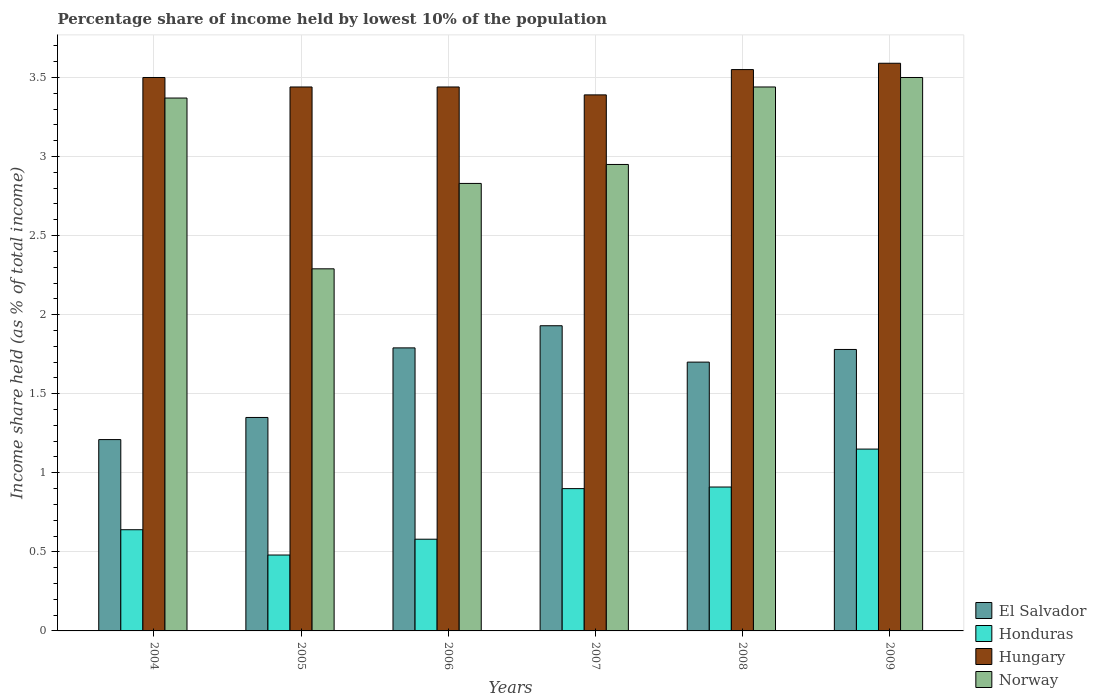Are the number of bars per tick equal to the number of legend labels?
Offer a terse response. Yes. Are the number of bars on each tick of the X-axis equal?
Your answer should be very brief. Yes. What is the label of the 6th group of bars from the left?
Your answer should be compact. 2009. What is the percentage share of income held by lowest 10% of the population in El Salvador in 2007?
Offer a terse response. 1.93. Across all years, what is the maximum percentage share of income held by lowest 10% of the population in Hungary?
Your response must be concise. 3.59. Across all years, what is the minimum percentage share of income held by lowest 10% of the population in Norway?
Provide a short and direct response. 2.29. In which year was the percentage share of income held by lowest 10% of the population in Honduras minimum?
Your answer should be compact. 2005. What is the total percentage share of income held by lowest 10% of the population in Hungary in the graph?
Give a very brief answer. 20.91. What is the difference between the percentage share of income held by lowest 10% of the population in El Salvador in 2007 and that in 2008?
Your answer should be compact. 0.23. What is the difference between the percentage share of income held by lowest 10% of the population in Norway in 2009 and the percentage share of income held by lowest 10% of the population in El Salvador in 2004?
Ensure brevity in your answer.  2.29. What is the average percentage share of income held by lowest 10% of the population in Hungary per year?
Make the answer very short. 3.48. In the year 2009, what is the difference between the percentage share of income held by lowest 10% of the population in El Salvador and percentage share of income held by lowest 10% of the population in Honduras?
Provide a succinct answer. 0.63. What is the ratio of the percentage share of income held by lowest 10% of the population in Norway in 2004 to that in 2006?
Provide a succinct answer. 1.19. Is the percentage share of income held by lowest 10% of the population in Honduras in 2006 less than that in 2009?
Offer a terse response. Yes. What is the difference between the highest and the second highest percentage share of income held by lowest 10% of the population in Hungary?
Your answer should be very brief. 0.04. What is the difference between the highest and the lowest percentage share of income held by lowest 10% of the population in Norway?
Provide a short and direct response. 1.21. In how many years, is the percentage share of income held by lowest 10% of the population in Hungary greater than the average percentage share of income held by lowest 10% of the population in Hungary taken over all years?
Ensure brevity in your answer.  3. Is it the case that in every year, the sum of the percentage share of income held by lowest 10% of the population in El Salvador and percentage share of income held by lowest 10% of the population in Norway is greater than the sum of percentage share of income held by lowest 10% of the population in Honduras and percentage share of income held by lowest 10% of the population in Hungary?
Your answer should be very brief. Yes. What does the 3rd bar from the right in 2008 represents?
Make the answer very short. Honduras. Is it the case that in every year, the sum of the percentage share of income held by lowest 10% of the population in Norway and percentage share of income held by lowest 10% of the population in Honduras is greater than the percentage share of income held by lowest 10% of the population in Hungary?
Your answer should be compact. No. Are all the bars in the graph horizontal?
Keep it short and to the point. No. Does the graph contain any zero values?
Your response must be concise. No. Does the graph contain grids?
Ensure brevity in your answer.  Yes. Where does the legend appear in the graph?
Offer a very short reply. Bottom right. How are the legend labels stacked?
Keep it short and to the point. Vertical. What is the title of the graph?
Provide a short and direct response. Percentage share of income held by lowest 10% of the population. Does "Zambia" appear as one of the legend labels in the graph?
Ensure brevity in your answer.  No. What is the label or title of the Y-axis?
Your answer should be very brief. Income share held (as % of total income). What is the Income share held (as % of total income) of El Salvador in 2004?
Keep it short and to the point. 1.21. What is the Income share held (as % of total income) in Honduras in 2004?
Ensure brevity in your answer.  0.64. What is the Income share held (as % of total income) in Norway in 2004?
Provide a succinct answer. 3.37. What is the Income share held (as % of total income) of El Salvador in 2005?
Offer a very short reply. 1.35. What is the Income share held (as % of total income) of Honduras in 2005?
Ensure brevity in your answer.  0.48. What is the Income share held (as % of total income) of Hungary in 2005?
Provide a short and direct response. 3.44. What is the Income share held (as % of total income) of Norway in 2005?
Keep it short and to the point. 2.29. What is the Income share held (as % of total income) of El Salvador in 2006?
Provide a succinct answer. 1.79. What is the Income share held (as % of total income) in Honduras in 2006?
Ensure brevity in your answer.  0.58. What is the Income share held (as % of total income) in Hungary in 2006?
Offer a terse response. 3.44. What is the Income share held (as % of total income) in Norway in 2006?
Give a very brief answer. 2.83. What is the Income share held (as % of total income) in El Salvador in 2007?
Ensure brevity in your answer.  1.93. What is the Income share held (as % of total income) in Honduras in 2007?
Offer a terse response. 0.9. What is the Income share held (as % of total income) of Hungary in 2007?
Provide a short and direct response. 3.39. What is the Income share held (as % of total income) in Norway in 2007?
Provide a succinct answer. 2.95. What is the Income share held (as % of total income) in Honduras in 2008?
Your response must be concise. 0.91. What is the Income share held (as % of total income) in Hungary in 2008?
Make the answer very short. 3.55. What is the Income share held (as % of total income) in Norway in 2008?
Offer a terse response. 3.44. What is the Income share held (as % of total income) of El Salvador in 2009?
Make the answer very short. 1.78. What is the Income share held (as % of total income) of Honduras in 2009?
Offer a very short reply. 1.15. What is the Income share held (as % of total income) of Hungary in 2009?
Provide a short and direct response. 3.59. Across all years, what is the maximum Income share held (as % of total income) in El Salvador?
Your response must be concise. 1.93. Across all years, what is the maximum Income share held (as % of total income) in Honduras?
Your response must be concise. 1.15. Across all years, what is the maximum Income share held (as % of total income) in Hungary?
Your answer should be compact. 3.59. Across all years, what is the maximum Income share held (as % of total income) in Norway?
Offer a very short reply. 3.5. Across all years, what is the minimum Income share held (as % of total income) of El Salvador?
Your answer should be very brief. 1.21. Across all years, what is the minimum Income share held (as % of total income) of Honduras?
Your response must be concise. 0.48. Across all years, what is the minimum Income share held (as % of total income) in Hungary?
Your answer should be very brief. 3.39. Across all years, what is the minimum Income share held (as % of total income) in Norway?
Provide a short and direct response. 2.29. What is the total Income share held (as % of total income) of El Salvador in the graph?
Offer a terse response. 9.76. What is the total Income share held (as % of total income) of Honduras in the graph?
Provide a succinct answer. 4.66. What is the total Income share held (as % of total income) in Hungary in the graph?
Your answer should be very brief. 20.91. What is the total Income share held (as % of total income) in Norway in the graph?
Ensure brevity in your answer.  18.38. What is the difference between the Income share held (as % of total income) in El Salvador in 2004 and that in 2005?
Make the answer very short. -0.14. What is the difference between the Income share held (as % of total income) in Honduras in 2004 and that in 2005?
Make the answer very short. 0.16. What is the difference between the Income share held (as % of total income) of El Salvador in 2004 and that in 2006?
Make the answer very short. -0.58. What is the difference between the Income share held (as % of total income) in Norway in 2004 and that in 2006?
Your response must be concise. 0.54. What is the difference between the Income share held (as % of total income) in El Salvador in 2004 and that in 2007?
Offer a very short reply. -0.72. What is the difference between the Income share held (as % of total income) in Honduras in 2004 and that in 2007?
Keep it short and to the point. -0.26. What is the difference between the Income share held (as % of total income) of Hungary in 2004 and that in 2007?
Make the answer very short. 0.11. What is the difference between the Income share held (as % of total income) of Norway in 2004 and that in 2007?
Provide a succinct answer. 0.42. What is the difference between the Income share held (as % of total income) in El Salvador in 2004 and that in 2008?
Offer a terse response. -0.49. What is the difference between the Income share held (as % of total income) in Honduras in 2004 and that in 2008?
Provide a succinct answer. -0.27. What is the difference between the Income share held (as % of total income) in Hungary in 2004 and that in 2008?
Provide a short and direct response. -0.05. What is the difference between the Income share held (as % of total income) in Norway in 2004 and that in 2008?
Your response must be concise. -0.07. What is the difference between the Income share held (as % of total income) of El Salvador in 2004 and that in 2009?
Offer a terse response. -0.57. What is the difference between the Income share held (as % of total income) in Honduras in 2004 and that in 2009?
Your answer should be compact. -0.51. What is the difference between the Income share held (as % of total income) of Hungary in 2004 and that in 2009?
Provide a short and direct response. -0.09. What is the difference between the Income share held (as % of total income) of Norway in 2004 and that in 2009?
Your answer should be compact. -0.13. What is the difference between the Income share held (as % of total income) of El Salvador in 2005 and that in 2006?
Give a very brief answer. -0.44. What is the difference between the Income share held (as % of total income) in Honduras in 2005 and that in 2006?
Your response must be concise. -0.1. What is the difference between the Income share held (as % of total income) of Norway in 2005 and that in 2006?
Make the answer very short. -0.54. What is the difference between the Income share held (as % of total income) in El Salvador in 2005 and that in 2007?
Your answer should be very brief. -0.58. What is the difference between the Income share held (as % of total income) in Honduras in 2005 and that in 2007?
Offer a terse response. -0.42. What is the difference between the Income share held (as % of total income) of Hungary in 2005 and that in 2007?
Your answer should be very brief. 0.05. What is the difference between the Income share held (as % of total income) in Norway in 2005 and that in 2007?
Offer a terse response. -0.66. What is the difference between the Income share held (as % of total income) of El Salvador in 2005 and that in 2008?
Offer a very short reply. -0.35. What is the difference between the Income share held (as % of total income) of Honduras in 2005 and that in 2008?
Your answer should be very brief. -0.43. What is the difference between the Income share held (as % of total income) in Hungary in 2005 and that in 2008?
Provide a short and direct response. -0.11. What is the difference between the Income share held (as % of total income) of Norway in 2005 and that in 2008?
Offer a terse response. -1.15. What is the difference between the Income share held (as % of total income) in El Salvador in 2005 and that in 2009?
Your answer should be very brief. -0.43. What is the difference between the Income share held (as % of total income) in Honduras in 2005 and that in 2009?
Your answer should be compact. -0.67. What is the difference between the Income share held (as % of total income) of Hungary in 2005 and that in 2009?
Provide a succinct answer. -0.15. What is the difference between the Income share held (as % of total income) in Norway in 2005 and that in 2009?
Your answer should be compact. -1.21. What is the difference between the Income share held (as % of total income) in El Salvador in 2006 and that in 2007?
Your response must be concise. -0.14. What is the difference between the Income share held (as % of total income) of Honduras in 2006 and that in 2007?
Your answer should be very brief. -0.32. What is the difference between the Income share held (as % of total income) in Norway in 2006 and that in 2007?
Give a very brief answer. -0.12. What is the difference between the Income share held (as % of total income) of El Salvador in 2006 and that in 2008?
Offer a very short reply. 0.09. What is the difference between the Income share held (as % of total income) of Honduras in 2006 and that in 2008?
Offer a terse response. -0.33. What is the difference between the Income share held (as % of total income) in Hungary in 2006 and that in 2008?
Provide a succinct answer. -0.11. What is the difference between the Income share held (as % of total income) in Norway in 2006 and that in 2008?
Keep it short and to the point. -0.61. What is the difference between the Income share held (as % of total income) in Honduras in 2006 and that in 2009?
Give a very brief answer. -0.57. What is the difference between the Income share held (as % of total income) of Norway in 2006 and that in 2009?
Make the answer very short. -0.67. What is the difference between the Income share held (as % of total income) in El Salvador in 2007 and that in 2008?
Your answer should be very brief. 0.23. What is the difference between the Income share held (as % of total income) in Honduras in 2007 and that in 2008?
Offer a very short reply. -0.01. What is the difference between the Income share held (as % of total income) of Hungary in 2007 and that in 2008?
Provide a succinct answer. -0.16. What is the difference between the Income share held (as % of total income) of Norway in 2007 and that in 2008?
Offer a very short reply. -0.49. What is the difference between the Income share held (as % of total income) of Hungary in 2007 and that in 2009?
Offer a terse response. -0.2. What is the difference between the Income share held (as % of total income) in Norway in 2007 and that in 2009?
Your answer should be compact. -0.55. What is the difference between the Income share held (as % of total income) of El Salvador in 2008 and that in 2009?
Your answer should be compact. -0.08. What is the difference between the Income share held (as % of total income) of Honduras in 2008 and that in 2009?
Provide a succinct answer. -0.24. What is the difference between the Income share held (as % of total income) of Hungary in 2008 and that in 2009?
Your answer should be very brief. -0.04. What is the difference between the Income share held (as % of total income) of Norway in 2008 and that in 2009?
Keep it short and to the point. -0.06. What is the difference between the Income share held (as % of total income) in El Salvador in 2004 and the Income share held (as % of total income) in Honduras in 2005?
Provide a short and direct response. 0.73. What is the difference between the Income share held (as % of total income) in El Salvador in 2004 and the Income share held (as % of total income) in Hungary in 2005?
Make the answer very short. -2.23. What is the difference between the Income share held (as % of total income) in El Salvador in 2004 and the Income share held (as % of total income) in Norway in 2005?
Give a very brief answer. -1.08. What is the difference between the Income share held (as % of total income) of Honduras in 2004 and the Income share held (as % of total income) of Hungary in 2005?
Provide a short and direct response. -2.8. What is the difference between the Income share held (as % of total income) in Honduras in 2004 and the Income share held (as % of total income) in Norway in 2005?
Your response must be concise. -1.65. What is the difference between the Income share held (as % of total income) of Hungary in 2004 and the Income share held (as % of total income) of Norway in 2005?
Give a very brief answer. 1.21. What is the difference between the Income share held (as % of total income) of El Salvador in 2004 and the Income share held (as % of total income) of Honduras in 2006?
Provide a succinct answer. 0.63. What is the difference between the Income share held (as % of total income) of El Salvador in 2004 and the Income share held (as % of total income) of Hungary in 2006?
Provide a short and direct response. -2.23. What is the difference between the Income share held (as % of total income) of El Salvador in 2004 and the Income share held (as % of total income) of Norway in 2006?
Offer a terse response. -1.62. What is the difference between the Income share held (as % of total income) in Honduras in 2004 and the Income share held (as % of total income) in Hungary in 2006?
Keep it short and to the point. -2.8. What is the difference between the Income share held (as % of total income) of Honduras in 2004 and the Income share held (as % of total income) of Norway in 2006?
Offer a terse response. -2.19. What is the difference between the Income share held (as % of total income) of Hungary in 2004 and the Income share held (as % of total income) of Norway in 2006?
Offer a terse response. 0.67. What is the difference between the Income share held (as % of total income) in El Salvador in 2004 and the Income share held (as % of total income) in Honduras in 2007?
Offer a very short reply. 0.31. What is the difference between the Income share held (as % of total income) of El Salvador in 2004 and the Income share held (as % of total income) of Hungary in 2007?
Your answer should be very brief. -2.18. What is the difference between the Income share held (as % of total income) of El Salvador in 2004 and the Income share held (as % of total income) of Norway in 2007?
Offer a terse response. -1.74. What is the difference between the Income share held (as % of total income) of Honduras in 2004 and the Income share held (as % of total income) of Hungary in 2007?
Offer a terse response. -2.75. What is the difference between the Income share held (as % of total income) of Honduras in 2004 and the Income share held (as % of total income) of Norway in 2007?
Offer a terse response. -2.31. What is the difference between the Income share held (as % of total income) of Hungary in 2004 and the Income share held (as % of total income) of Norway in 2007?
Provide a succinct answer. 0.55. What is the difference between the Income share held (as % of total income) of El Salvador in 2004 and the Income share held (as % of total income) of Honduras in 2008?
Your answer should be very brief. 0.3. What is the difference between the Income share held (as % of total income) of El Salvador in 2004 and the Income share held (as % of total income) of Hungary in 2008?
Give a very brief answer. -2.34. What is the difference between the Income share held (as % of total income) of El Salvador in 2004 and the Income share held (as % of total income) of Norway in 2008?
Make the answer very short. -2.23. What is the difference between the Income share held (as % of total income) of Honduras in 2004 and the Income share held (as % of total income) of Hungary in 2008?
Ensure brevity in your answer.  -2.91. What is the difference between the Income share held (as % of total income) of Honduras in 2004 and the Income share held (as % of total income) of Norway in 2008?
Make the answer very short. -2.8. What is the difference between the Income share held (as % of total income) in El Salvador in 2004 and the Income share held (as % of total income) in Hungary in 2009?
Your response must be concise. -2.38. What is the difference between the Income share held (as % of total income) in El Salvador in 2004 and the Income share held (as % of total income) in Norway in 2009?
Provide a short and direct response. -2.29. What is the difference between the Income share held (as % of total income) of Honduras in 2004 and the Income share held (as % of total income) of Hungary in 2009?
Your response must be concise. -2.95. What is the difference between the Income share held (as % of total income) of Honduras in 2004 and the Income share held (as % of total income) of Norway in 2009?
Your response must be concise. -2.86. What is the difference between the Income share held (as % of total income) of Hungary in 2004 and the Income share held (as % of total income) of Norway in 2009?
Ensure brevity in your answer.  0. What is the difference between the Income share held (as % of total income) of El Salvador in 2005 and the Income share held (as % of total income) of Honduras in 2006?
Offer a very short reply. 0.77. What is the difference between the Income share held (as % of total income) in El Salvador in 2005 and the Income share held (as % of total income) in Hungary in 2006?
Offer a terse response. -2.09. What is the difference between the Income share held (as % of total income) in El Salvador in 2005 and the Income share held (as % of total income) in Norway in 2006?
Ensure brevity in your answer.  -1.48. What is the difference between the Income share held (as % of total income) in Honduras in 2005 and the Income share held (as % of total income) in Hungary in 2006?
Offer a terse response. -2.96. What is the difference between the Income share held (as % of total income) of Honduras in 2005 and the Income share held (as % of total income) of Norway in 2006?
Your answer should be compact. -2.35. What is the difference between the Income share held (as % of total income) in Hungary in 2005 and the Income share held (as % of total income) in Norway in 2006?
Provide a succinct answer. 0.61. What is the difference between the Income share held (as % of total income) of El Salvador in 2005 and the Income share held (as % of total income) of Honduras in 2007?
Give a very brief answer. 0.45. What is the difference between the Income share held (as % of total income) in El Salvador in 2005 and the Income share held (as % of total income) in Hungary in 2007?
Offer a terse response. -2.04. What is the difference between the Income share held (as % of total income) in El Salvador in 2005 and the Income share held (as % of total income) in Norway in 2007?
Give a very brief answer. -1.6. What is the difference between the Income share held (as % of total income) in Honduras in 2005 and the Income share held (as % of total income) in Hungary in 2007?
Your response must be concise. -2.91. What is the difference between the Income share held (as % of total income) of Honduras in 2005 and the Income share held (as % of total income) of Norway in 2007?
Offer a terse response. -2.47. What is the difference between the Income share held (as % of total income) in Hungary in 2005 and the Income share held (as % of total income) in Norway in 2007?
Your answer should be compact. 0.49. What is the difference between the Income share held (as % of total income) in El Salvador in 2005 and the Income share held (as % of total income) in Honduras in 2008?
Your response must be concise. 0.44. What is the difference between the Income share held (as % of total income) of El Salvador in 2005 and the Income share held (as % of total income) of Hungary in 2008?
Make the answer very short. -2.2. What is the difference between the Income share held (as % of total income) in El Salvador in 2005 and the Income share held (as % of total income) in Norway in 2008?
Keep it short and to the point. -2.09. What is the difference between the Income share held (as % of total income) in Honduras in 2005 and the Income share held (as % of total income) in Hungary in 2008?
Provide a short and direct response. -3.07. What is the difference between the Income share held (as % of total income) in Honduras in 2005 and the Income share held (as % of total income) in Norway in 2008?
Offer a terse response. -2.96. What is the difference between the Income share held (as % of total income) of El Salvador in 2005 and the Income share held (as % of total income) of Hungary in 2009?
Your response must be concise. -2.24. What is the difference between the Income share held (as % of total income) of El Salvador in 2005 and the Income share held (as % of total income) of Norway in 2009?
Offer a very short reply. -2.15. What is the difference between the Income share held (as % of total income) in Honduras in 2005 and the Income share held (as % of total income) in Hungary in 2009?
Your answer should be very brief. -3.11. What is the difference between the Income share held (as % of total income) of Honduras in 2005 and the Income share held (as % of total income) of Norway in 2009?
Ensure brevity in your answer.  -3.02. What is the difference between the Income share held (as % of total income) in Hungary in 2005 and the Income share held (as % of total income) in Norway in 2009?
Provide a short and direct response. -0.06. What is the difference between the Income share held (as % of total income) in El Salvador in 2006 and the Income share held (as % of total income) in Honduras in 2007?
Offer a very short reply. 0.89. What is the difference between the Income share held (as % of total income) of El Salvador in 2006 and the Income share held (as % of total income) of Norway in 2007?
Your response must be concise. -1.16. What is the difference between the Income share held (as % of total income) of Honduras in 2006 and the Income share held (as % of total income) of Hungary in 2007?
Ensure brevity in your answer.  -2.81. What is the difference between the Income share held (as % of total income) of Honduras in 2006 and the Income share held (as % of total income) of Norway in 2007?
Your answer should be very brief. -2.37. What is the difference between the Income share held (as % of total income) of Hungary in 2006 and the Income share held (as % of total income) of Norway in 2007?
Provide a short and direct response. 0.49. What is the difference between the Income share held (as % of total income) in El Salvador in 2006 and the Income share held (as % of total income) in Hungary in 2008?
Your answer should be compact. -1.76. What is the difference between the Income share held (as % of total income) in El Salvador in 2006 and the Income share held (as % of total income) in Norway in 2008?
Provide a succinct answer. -1.65. What is the difference between the Income share held (as % of total income) in Honduras in 2006 and the Income share held (as % of total income) in Hungary in 2008?
Your answer should be compact. -2.97. What is the difference between the Income share held (as % of total income) of Honduras in 2006 and the Income share held (as % of total income) of Norway in 2008?
Give a very brief answer. -2.86. What is the difference between the Income share held (as % of total income) of Hungary in 2006 and the Income share held (as % of total income) of Norway in 2008?
Offer a terse response. 0. What is the difference between the Income share held (as % of total income) in El Salvador in 2006 and the Income share held (as % of total income) in Honduras in 2009?
Make the answer very short. 0.64. What is the difference between the Income share held (as % of total income) of El Salvador in 2006 and the Income share held (as % of total income) of Hungary in 2009?
Provide a short and direct response. -1.8. What is the difference between the Income share held (as % of total income) in El Salvador in 2006 and the Income share held (as % of total income) in Norway in 2009?
Provide a succinct answer. -1.71. What is the difference between the Income share held (as % of total income) in Honduras in 2006 and the Income share held (as % of total income) in Hungary in 2009?
Offer a very short reply. -3.01. What is the difference between the Income share held (as % of total income) of Honduras in 2006 and the Income share held (as % of total income) of Norway in 2009?
Your answer should be compact. -2.92. What is the difference between the Income share held (as % of total income) in Hungary in 2006 and the Income share held (as % of total income) in Norway in 2009?
Ensure brevity in your answer.  -0.06. What is the difference between the Income share held (as % of total income) in El Salvador in 2007 and the Income share held (as % of total income) in Hungary in 2008?
Your response must be concise. -1.62. What is the difference between the Income share held (as % of total income) in El Salvador in 2007 and the Income share held (as % of total income) in Norway in 2008?
Keep it short and to the point. -1.51. What is the difference between the Income share held (as % of total income) of Honduras in 2007 and the Income share held (as % of total income) of Hungary in 2008?
Ensure brevity in your answer.  -2.65. What is the difference between the Income share held (as % of total income) of Honduras in 2007 and the Income share held (as % of total income) of Norway in 2008?
Provide a succinct answer. -2.54. What is the difference between the Income share held (as % of total income) of Hungary in 2007 and the Income share held (as % of total income) of Norway in 2008?
Keep it short and to the point. -0.05. What is the difference between the Income share held (as % of total income) in El Salvador in 2007 and the Income share held (as % of total income) in Honduras in 2009?
Give a very brief answer. 0.78. What is the difference between the Income share held (as % of total income) of El Salvador in 2007 and the Income share held (as % of total income) of Hungary in 2009?
Give a very brief answer. -1.66. What is the difference between the Income share held (as % of total income) in El Salvador in 2007 and the Income share held (as % of total income) in Norway in 2009?
Your answer should be compact. -1.57. What is the difference between the Income share held (as % of total income) of Honduras in 2007 and the Income share held (as % of total income) of Hungary in 2009?
Ensure brevity in your answer.  -2.69. What is the difference between the Income share held (as % of total income) in Hungary in 2007 and the Income share held (as % of total income) in Norway in 2009?
Your answer should be compact. -0.11. What is the difference between the Income share held (as % of total income) of El Salvador in 2008 and the Income share held (as % of total income) of Honduras in 2009?
Ensure brevity in your answer.  0.55. What is the difference between the Income share held (as % of total income) in El Salvador in 2008 and the Income share held (as % of total income) in Hungary in 2009?
Your answer should be very brief. -1.89. What is the difference between the Income share held (as % of total income) of El Salvador in 2008 and the Income share held (as % of total income) of Norway in 2009?
Your answer should be very brief. -1.8. What is the difference between the Income share held (as % of total income) of Honduras in 2008 and the Income share held (as % of total income) of Hungary in 2009?
Keep it short and to the point. -2.68. What is the difference between the Income share held (as % of total income) in Honduras in 2008 and the Income share held (as % of total income) in Norway in 2009?
Offer a very short reply. -2.59. What is the average Income share held (as % of total income) of El Salvador per year?
Give a very brief answer. 1.63. What is the average Income share held (as % of total income) of Honduras per year?
Your answer should be compact. 0.78. What is the average Income share held (as % of total income) in Hungary per year?
Your answer should be compact. 3.48. What is the average Income share held (as % of total income) of Norway per year?
Offer a terse response. 3.06. In the year 2004, what is the difference between the Income share held (as % of total income) of El Salvador and Income share held (as % of total income) of Honduras?
Your answer should be very brief. 0.57. In the year 2004, what is the difference between the Income share held (as % of total income) in El Salvador and Income share held (as % of total income) in Hungary?
Your answer should be compact. -2.29. In the year 2004, what is the difference between the Income share held (as % of total income) in El Salvador and Income share held (as % of total income) in Norway?
Offer a terse response. -2.16. In the year 2004, what is the difference between the Income share held (as % of total income) in Honduras and Income share held (as % of total income) in Hungary?
Keep it short and to the point. -2.86. In the year 2004, what is the difference between the Income share held (as % of total income) in Honduras and Income share held (as % of total income) in Norway?
Provide a short and direct response. -2.73. In the year 2004, what is the difference between the Income share held (as % of total income) of Hungary and Income share held (as % of total income) of Norway?
Provide a succinct answer. 0.13. In the year 2005, what is the difference between the Income share held (as % of total income) of El Salvador and Income share held (as % of total income) of Honduras?
Offer a very short reply. 0.87. In the year 2005, what is the difference between the Income share held (as % of total income) of El Salvador and Income share held (as % of total income) of Hungary?
Offer a very short reply. -2.09. In the year 2005, what is the difference between the Income share held (as % of total income) of El Salvador and Income share held (as % of total income) of Norway?
Give a very brief answer. -0.94. In the year 2005, what is the difference between the Income share held (as % of total income) in Honduras and Income share held (as % of total income) in Hungary?
Provide a succinct answer. -2.96. In the year 2005, what is the difference between the Income share held (as % of total income) in Honduras and Income share held (as % of total income) in Norway?
Make the answer very short. -1.81. In the year 2005, what is the difference between the Income share held (as % of total income) in Hungary and Income share held (as % of total income) in Norway?
Provide a short and direct response. 1.15. In the year 2006, what is the difference between the Income share held (as % of total income) in El Salvador and Income share held (as % of total income) in Honduras?
Provide a short and direct response. 1.21. In the year 2006, what is the difference between the Income share held (as % of total income) in El Salvador and Income share held (as % of total income) in Hungary?
Offer a terse response. -1.65. In the year 2006, what is the difference between the Income share held (as % of total income) in El Salvador and Income share held (as % of total income) in Norway?
Your answer should be compact. -1.04. In the year 2006, what is the difference between the Income share held (as % of total income) in Honduras and Income share held (as % of total income) in Hungary?
Your response must be concise. -2.86. In the year 2006, what is the difference between the Income share held (as % of total income) in Honduras and Income share held (as % of total income) in Norway?
Give a very brief answer. -2.25. In the year 2006, what is the difference between the Income share held (as % of total income) in Hungary and Income share held (as % of total income) in Norway?
Your response must be concise. 0.61. In the year 2007, what is the difference between the Income share held (as % of total income) in El Salvador and Income share held (as % of total income) in Hungary?
Give a very brief answer. -1.46. In the year 2007, what is the difference between the Income share held (as % of total income) in El Salvador and Income share held (as % of total income) in Norway?
Make the answer very short. -1.02. In the year 2007, what is the difference between the Income share held (as % of total income) in Honduras and Income share held (as % of total income) in Hungary?
Make the answer very short. -2.49. In the year 2007, what is the difference between the Income share held (as % of total income) of Honduras and Income share held (as % of total income) of Norway?
Your answer should be compact. -2.05. In the year 2007, what is the difference between the Income share held (as % of total income) of Hungary and Income share held (as % of total income) of Norway?
Provide a succinct answer. 0.44. In the year 2008, what is the difference between the Income share held (as % of total income) of El Salvador and Income share held (as % of total income) of Honduras?
Give a very brief answer. 0.79. In the year 2008, what is the difference between the Income share held (as % of total income) of El Salvador and Income share held (as % of total income) of Hungary?
Ensure brevity in your answer.  -1.85. In the year 2008, what is the difference between the Income share held (as % of total income) of El Salvador and Income share held (as % of total income) of Norway?
Give a very brief answer. -1.74. In the year 2008, what is the difference between the Income share held (as % of total income) in Honduras and Income share held (as % of total income) in Hungary?
Your response must be concise. -2.64. In the year 2008, what is the difference between the Income share held (as % of total income) in Honduras and Income share held (as % of total income) in Norway?
Your response must be concise. -2.53. In the year 2008, what is the difference between the Income share held (as % of total income) of Hungary and Income share held (as % of total income) of Norway?
Keep it short and to the point. 0.11. In the year 2009, what is the difference between the Income share held (as % of total income) of El Salvador and Income share held (as % of total income) of Honduras?
Provide a short and direct response. 0.63. In the year 2009, what is the difference between the Income share held (as % of total income) in El Salvador and Income share held (as % of total income) in Hungary?
Your answer should be compact. -1.81. In the year 2009, what is the difference between the Income share held (as % of total income) in El Salvador and Income share held (as % of total income) in Norway?
Offer a very short reply. -1.72. In the year 2009, what is the difference between the Income share held (as % of total income) in Honduras and Income share held (as % of total income) in Hungary?
Give a very brief answer. -2.44. In the year 2009, what is the difference between the Income share held (as % of total income) in Honduras and Income share held (as % of total income) in Norway?
Make the answer very short. -2.35. In the year 2009, what is the difference between the Income share held (as % of total income) in Hungary and Income share held (as % of total income) in Norway?
Make the answer very short. 0.09. What is the ratio of the Income share held (as % of total income) in El Salvador in 2004 to that in 2005?
Give a very brief answer. 0.9. What is the ratio of the Income share held (as % of total income) in Hungary in 2004 to that in 2005?
Your response must be concise. 1.02. What is the ratio of the Income share held (as % of total income) in Norway in 2004 to that in 2005?
Keep it short and to the point. 1.47. What is the ratio of the Income share held (as % of total income) of El Salvador in 2004 to that in 2006?
Offer a very short reply. 0.68. What is the ratio of the Income share held (as % of total income) in Honduras in 2004 to that in 2006?
Your answer should be very brief. 1.1. What is the ratio of the Income share held (as % of total income) in Hungary in 2004 to that in 2006?
Provide a short and direct response. 1.02. What is the ratio of the Income share held (as % of total income) of Norway in 2004 to that in 2006?
Your response must be concise. 1.19. What is the ratio of the Income share held (as % of total income) of El Salvador in 2004 to that in 2007?
Your response must be concise. 0.63. What is the ratio of the Income share held (as % of total income) of Honduras in 2004 to that in 2007?
Your answer should be very brief. 0.71. What is the ratio of the Income share held (as % of total income) in Hungary in 2004 to that in 2007?
Your response must be concise. 1.03. What is the ratio of the Income share held (as % of total income) in Norway in 2004 to that in 2007?
Make the answer very short. 1.14. What is the ratio of the Income share held (as % of total income) of El Salvador in 2004 to that in 2008?
Make the answer very short. 0.71. What is the ratio of the Income share held (as % of total income) of Honduras in 2004 to that in 2008?
Give a very brief answer. 0.7. What is the ratio of the Income share held (as % of total income) of Hungary in 2004 to that in 2008?
Give a very brief answer. 0.99. What is the ratio of the Income share held (as % of total income) of Norway in 2004 to that in 2008?
Your answer should be compact. 0.98. What is the ratio of the Income share held (as % of total income) of El Salvador in 2004 to that in 2009?
Ensure brevity in your answer.  0.68. What is the ratio of the Income share held (as % of total income) in Honduras in 2004 to that in 2009?
Your answer should be very brief. 0.56. What is the ratio of the Income share held (as % of total income) in Hungary in 2004 to that in 2009?
Give a very brief answer. 0.97. What is the ratio of the Income share held (as % of total income) of Norway in 2004 to that in 2009?
Your answer should be compact. 0.96. What is the ratio of the Income share held (as % of total income) in El Salvador in 2005 to that in 2006?
Give a very brief answer. 0.75. What is the ratio of the Income share held (as % of total income) in Honduras in 2005 to that in 2006?
Make the answer very short. 0.83. What is the ratio of the Income share held (as % of total income) of Hungary in 2005 to that in 2006?
Offer a very short reply. 1. What is the ratio of the Income share held (as % of total income) in Norway in 2005 to that in 2006?
Make the answer very short. 0.81. What is the ratio of the Income share held (as % of total income) of El Salvador in 2005 to that in 2007?
Ensure brevity in your answer.  0.7. What is the ratio of the Income share held (as % of total income) of Honduras in 2005 to that in 2007?
Provide a succinct answer. 0.53. What is the ratio of the Income share held (as % of total income) in Hungary in 2005 to that in 2007?
Your answer should be very brief. 1.01. What is the ratio of the Income share held (as % of total income) in Norway in 2005 to that in 2007?
Your response must be concise. 0.78. What is the ratio of the Income share held (as % of total income) in El Salvador in 2005 to that in 2008?
Make the answer very short. 0.79. What is the ratio of the Income share held (as % of total income) in Honduras in 2005 to that in 2008?
Your answer should be compact. 0.53. What is the ratio of the Income share held (as % of total income) of Hungary in 2005 to that in 2008?
Your response must be concise. 0.97. What is the ratio of the Income share held (as % of total income) of Norway in 2005 to that in 2008?
Make the answer very short. 0.67. What is the ratio of the Income share held (as % of total income) of El Salvador in 2005 to that in 2009?
Offer a terse response. 0.76. What is the ratio of the Income share held (as % of total income) of Honduras in 2005 to that in 2009?
Your answer should be very brief. 0.42. What is the ratio of the Income share held (as % of total income) in Hungary in 2005 to that in 2009?
Offer a terse response. 0.96. What is the ratio of the Income share held (as % of total income) in Norway in 2005 to that in 2009?
Offer a very short reply. 0.65. What is the ratio of the Income share held (as % of total income) in El Salvador in 2006 to that in 2007?
Your answer should be very brief. 0.93. What is the ratio of the Income share held (as % of total income) in Honduras in 2006 to that in 2007?
Keep it short and to the point. 0.64. What is the ratio of the Income share held (as % of total income) in Hungary in 2006 to that in 2007?
Provide a succinct answer. 1.01. What is the ratio of the Income share held (as % of total income) of Norway in 2006 to that in 2007?
Keep it short and to the point. 0.96. What is the ratio of the Income share held (as % of total income) of El Salvador in 2006 to that in 2008?
Your answer should be very brief. 1.05. What is the ratio of the Income share held (as % of total income) in Honduras in 2006 to that in 2008?
Ensure brevity in your answer.  0.64. What is the ratio of the Income share held (as % of total income) of Norway in 2006 to that in 2008?
Ensure brevity in your answer.  0.82. What is the ratio of the Income share held (as % of total income) of El Salvador in 2006 to that in 2009?
Provide a short and direct response. 1.01. What is the ratio of the Income share held (as % of total income) of Honduras in 2006 to that in 2009?
Ensure brevity in your answer.  0.5. What is the ratio of the Income share held (as % of total income) of Hungary in 2006 to that in 2009?
Keep it short and to the point. 0.96. What is the ratio of the Income share held (as % of total income) of Norway in 2006 to that in 2009?
Make the answer very short. 0.81. What is the ratio of the Income share held (as % of total income) of El Salvador in 2007 to that in 2008?
Your response must be concise. 1.14. What is the ratio of the Income share held (as % of total income) of Hungary in 2007 to that in 2008?
Keep it short and to the point. 0.95. What is the ratio of the Income share held (as % of total income) of Norway in 2007 to that in 2008?
Make the answer very short. 0.86. What is the ratio of the Income share held (as % of total income) of El Salvador in 2007 to that in 2009?
Your answer should be compact. 1.08. What is the ratio of the Income share held (as % of total income) in Honduras in 2007 to that in 2009?
Offer a very short reply. 0.78. What is the ratio of the Income share held (as % of total income) of Hungary in 2007 to that in 2009?
Offer a very short reply. 0.94. What is the ratio of the Income share held (as % of total income) in Norway in 2007 to that in 2009?
Give a very brief answer. 0.84. What is the ratio of the Income share held (as % of total income) of El Salvador in 2008 to that in 2009?
Your response must be concise. 0.96. What is the ratio of the Income share held (as % of total income) of Honduras in 2008 to that in 2009?
Make the answer very short. 0.79. What is the ratio of the Income share held (as % of total income) in Hungary in 2008 to that in 2009?
Offer a terse response. 0.99. What is the ratio of the Income share held (as % of total income) in Norway in 2008 to that in 2009?
Your response must be concise. 0.98. What is the difference between the highest and the second highest Income share held (as % of total income) in El Salvador?
Keep it short and to the point. 0.14. What is the difference between the highest and the second highest Income share held (as % of total income) of Honduras?
Provide a short and direct response. 0.24. What is the difference between the highest and the second highest Income share held (as % of total income) in Hungary?
Your answer should be compact. 0.04. What is the difference between the highest and the lowest Income share held (as % of total income) of El Salvador?
Make the answer very short. 0.72. What is the difference between the highest and the lowest Income share held (as % of total income) of Honduras?
Provide a short and direct response. 0.67. What is the difference between the highest and the lowest Income share held (as % of total income) of Norway?
Ensure brevity in your answer.  1.21. 